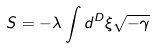Convert formula to latex. <formula><loc_0><loc_0><loc_500><loc_500>S = - \lambda \int d ^ { D } \xi \sqrt { - \gamma }</formula> 